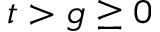<formula> <loc_0><loc_0><loc_500><loc_500>t > g \geq 0</formula> 